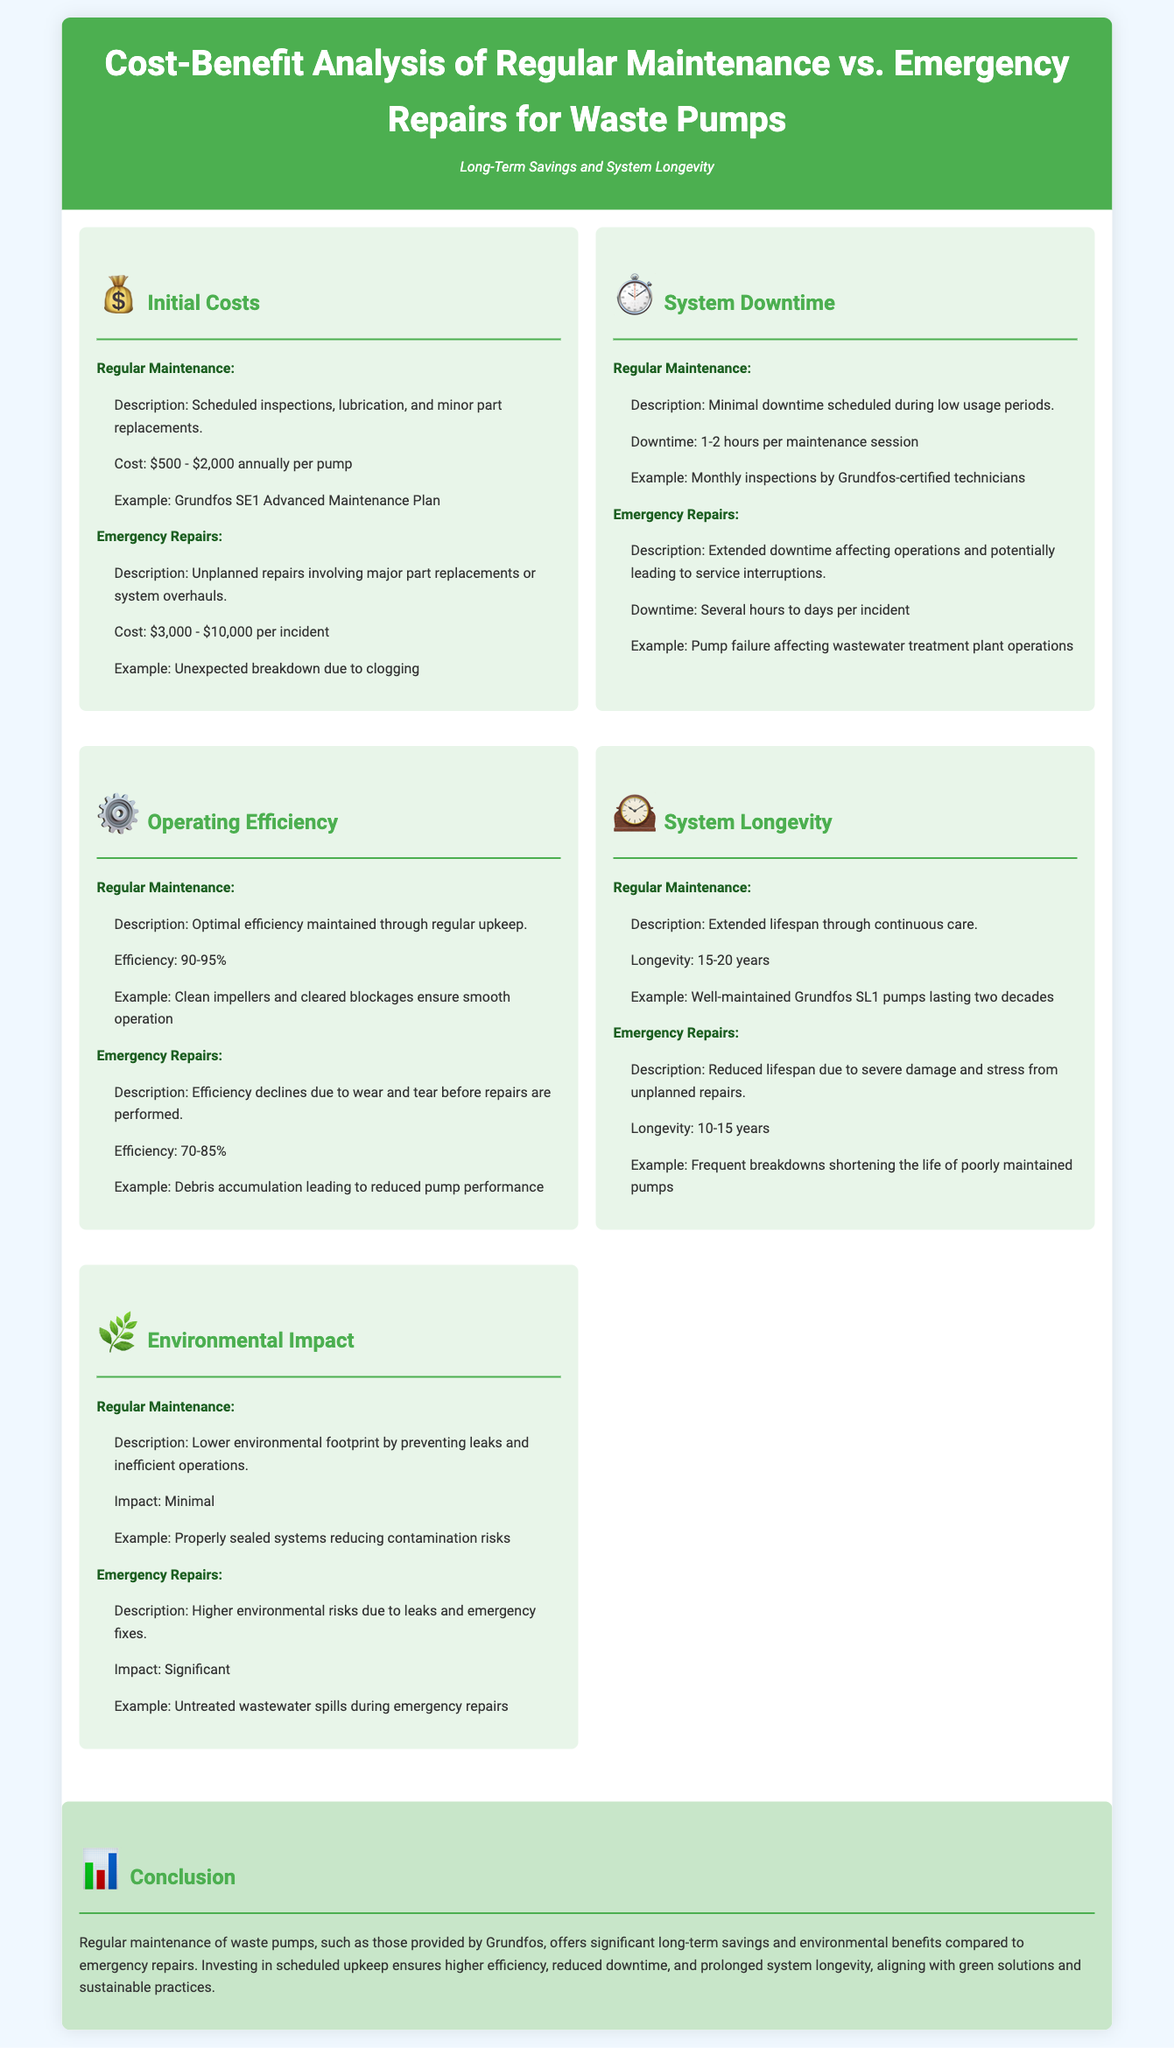what is the cost range for regular maintenance? The document states the cost for regular maintenance is between $500 and $2,000 annually per pump.
Answer: $500 - $2,000 what is the downtime for regular maintenance? According to the document, the downtime for regular maintenance is typically 1-2 hours per maintenance session.
Answer: 1-2 hours how much can emergency repairs cost per incident? The document mentions that emergency repairs can cost between $3,000 and $10,000 per incident.
Answer: $3,000 - $10,000 what efficiency percentage can be maintained with regular maintenance? The document indicates that regular maintenance can achieve an efficiency of 90-95%.
Answer: 90-95% which maintenance type offers a longer system longevity? The document states that regular maintenance extends system longevity compared to emergency repairs.
Answer: Regular Maintenance what is the lifespan advantage of regular maintenance over emergency repairs? The document points out that regular maintenance can extend the lifespan up to 20 years, while emergency repairs only extend it to 15 years.
Answer: 5 years how do regular maintenance and emergency repairs compare in environmental impact? The document compares the environmental impact, stating regular maintenance has minimal impact while emergency repairs have significant impact.
Answer: Significant what is the primary conclusion of the document? The conclusion emphasizes that regular maintenance provides significant long-term savings and environmental benefits over emergency repairs.
Answer: Long-term savings and environmental benefits what is an example of an unexpected issue leading to emergency repairs? The document gives an example of an unexpected breakdown due to clogging as a reason for emergency repairs.
Answer: Unexpected breakdown due to clogging how does scheduled maintenance affect operating efficiency? The document asserts that scheduled maintenance maintains optimal efficiency, while emergency repairs lead to efficiency decline.
Answer: Optimal efficiency 